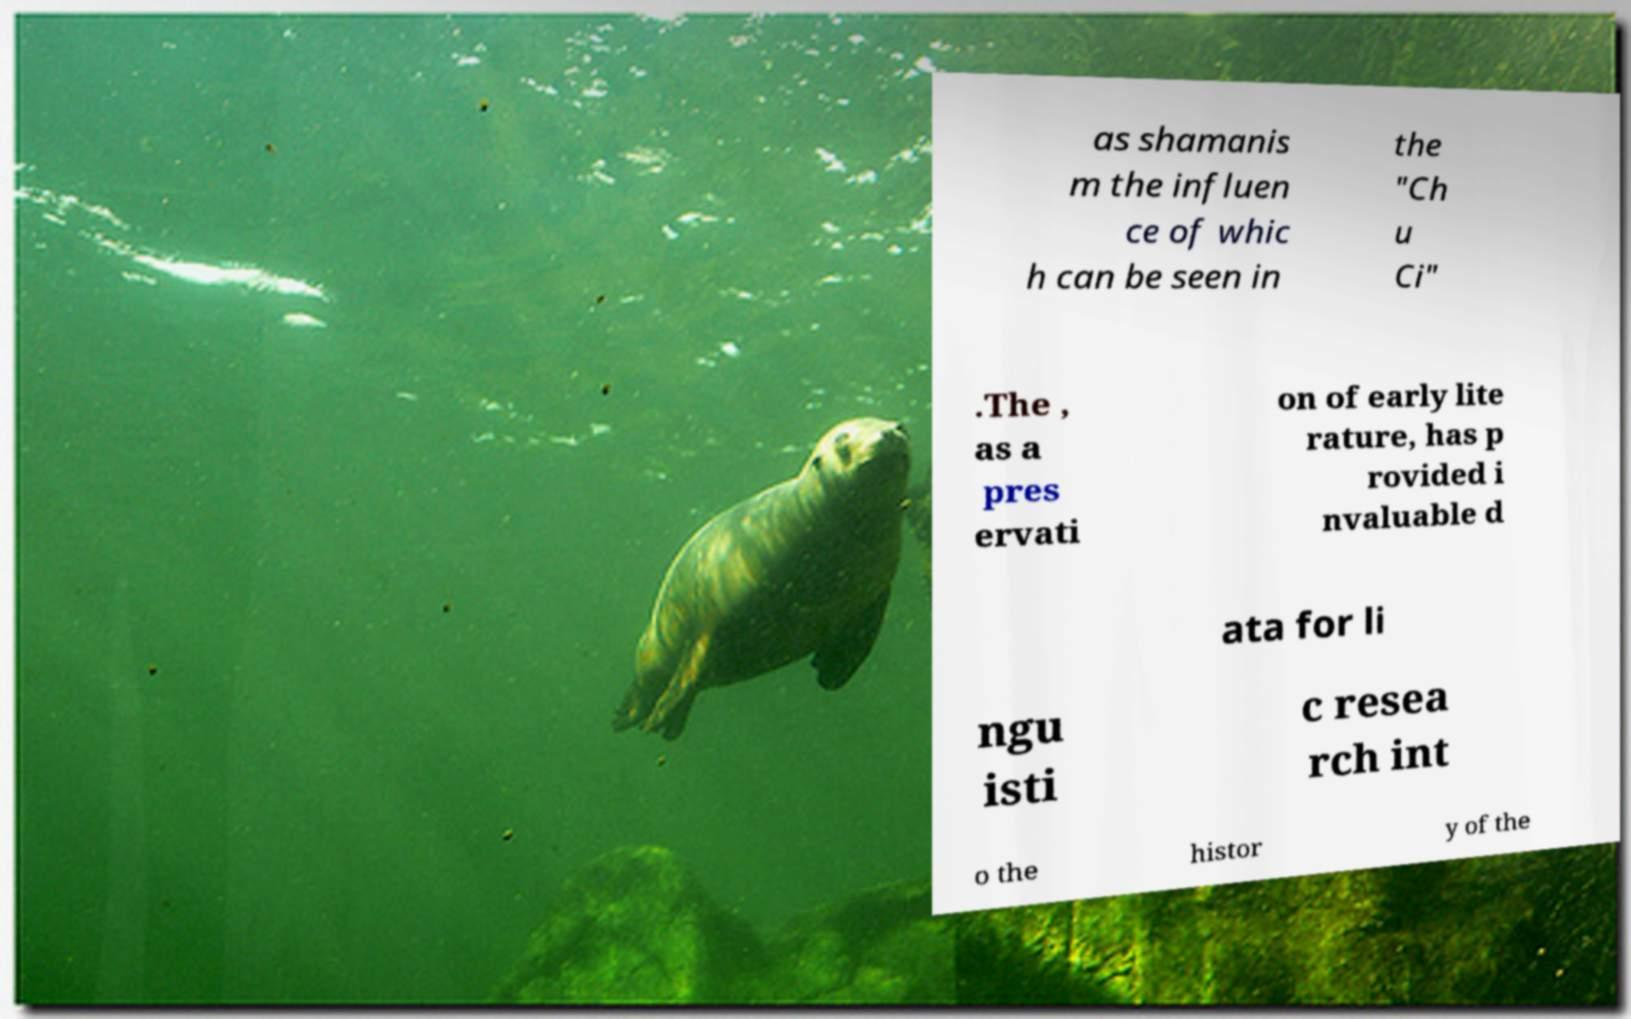Could you assist in decoding the text presented in this image and type it out clearly? as shamanis m the influen ce of whic h can be seen in the "Ch u Ci" .The , as a pres ervati on of early lite rature, has p rovided i nvaluable d ata for li ngu isti c resea rch int o the histor y of the 